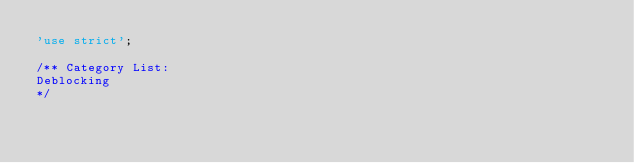Convert code to text. <code><loc_0><loc_0><loc_500><loc_500><_JavaScript_>'use strict';

/** Category List:
Deblocking
*/
</code> 